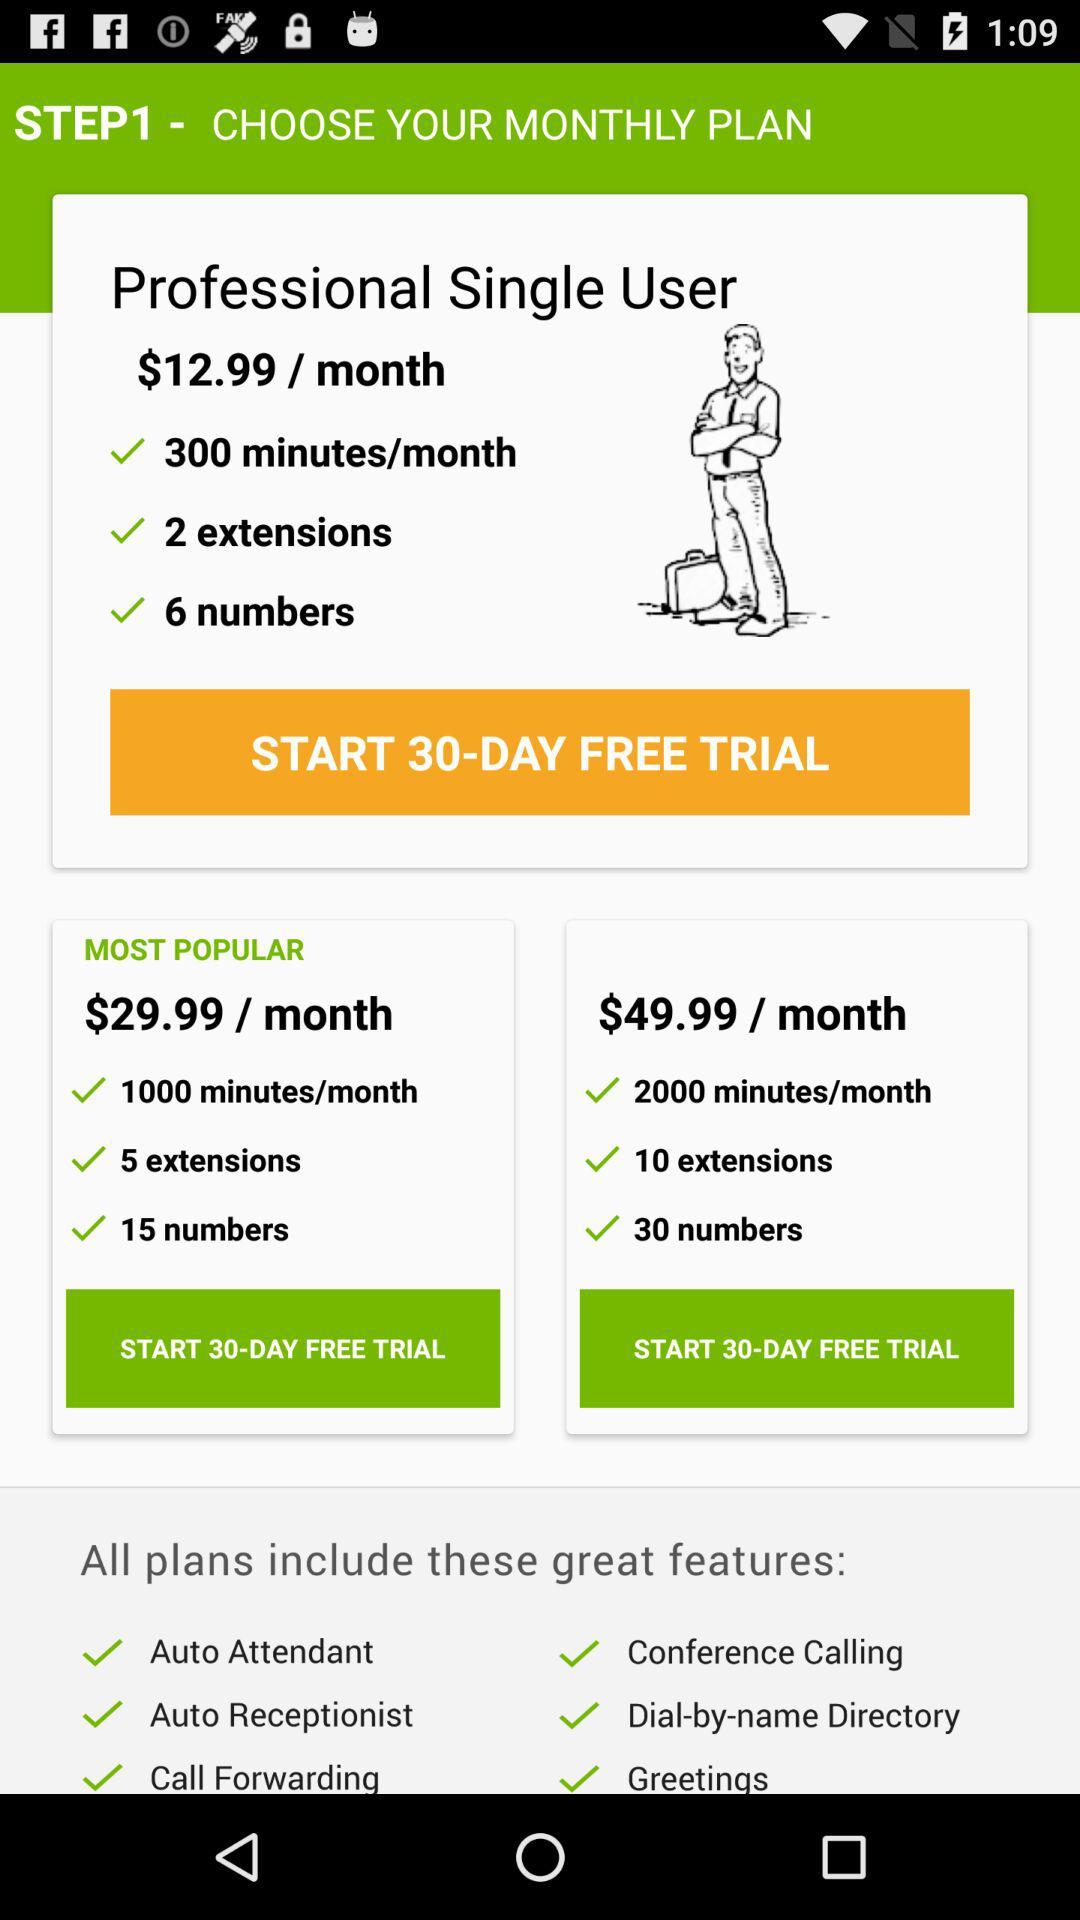Which plan do "15 numbers" belong to? "15 numbers" belong to the "MOST POPULAR" plan. 